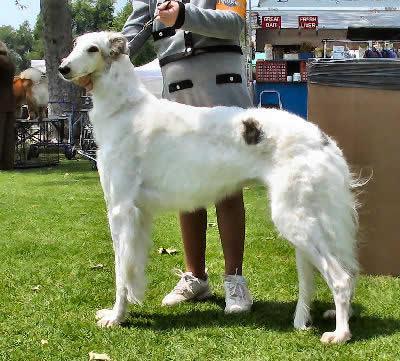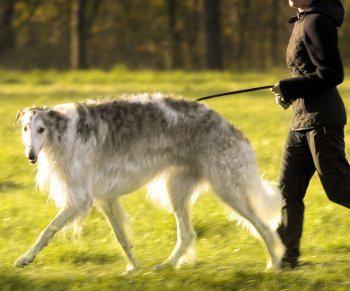The first image is the image on the left, the second image is the image on the right. Analyze the images presented: Is the assertion "There is only one dog in both pictures" valid? Answer yes or no. Yes. The first image is the image on the left, the second image is the image on the right. Given the left and right images, does the statement "There are more than two dogs present." hold true? Answer yes or no. No. 